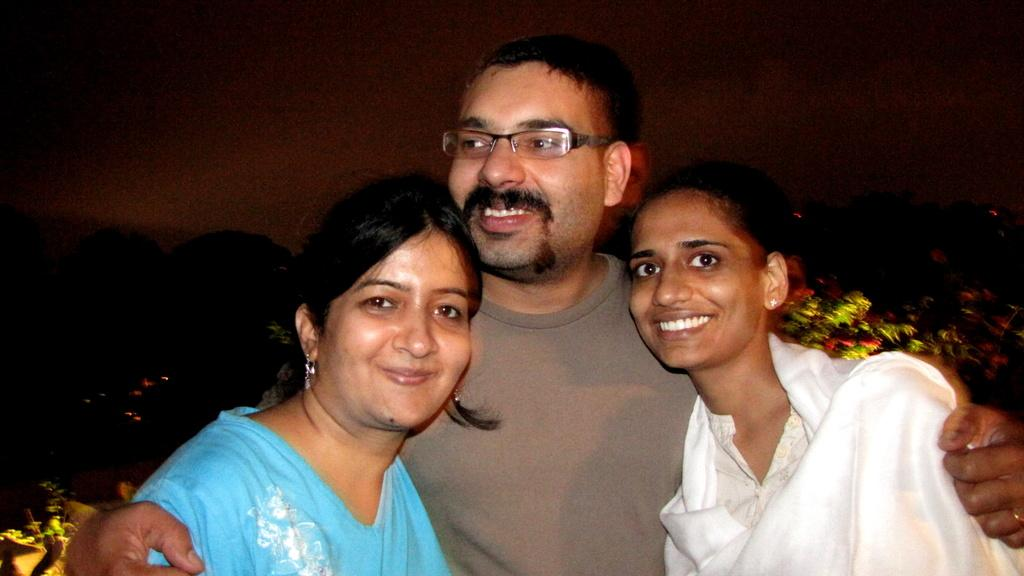How many people are in the foreground of the image? There are three people in the foreground of the image, including a man and two women. What can be seen in the middle of the image? There are plants in the middle of the image. What is the color of the background in the image? The background of the image is dark. What type of feather can be seen on the man's face in the image? There is no feather present on the man's face in the image. What company is represented by the logo on the women's shirts in the image? There is no logo or company mentioned in the image. 